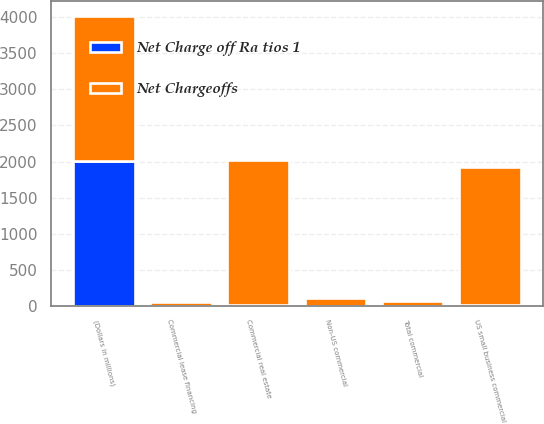<chart> <loc_0><loc_0><loc_500><loc_500><stacked_bar_chart><ecel><fcel>(Dollars in millions)<fcel>Commercial real estate<fcel>Commercial lease financing<fcel>Non-US commercial<fcel>US small business commercial<fcel>Total commercial<nl><fcel>Net Chargeoffs<fcel>2010<fcel>2017<fcel>57<fcel>111<fcel>1918<fcel>57<nl><fcel>Net Charge off Ra tios 1<fcel>2010<fcel>3.37<fcel>0.27<fcel>0.39<fcel>12<fcel>1.64<nl></chart> 